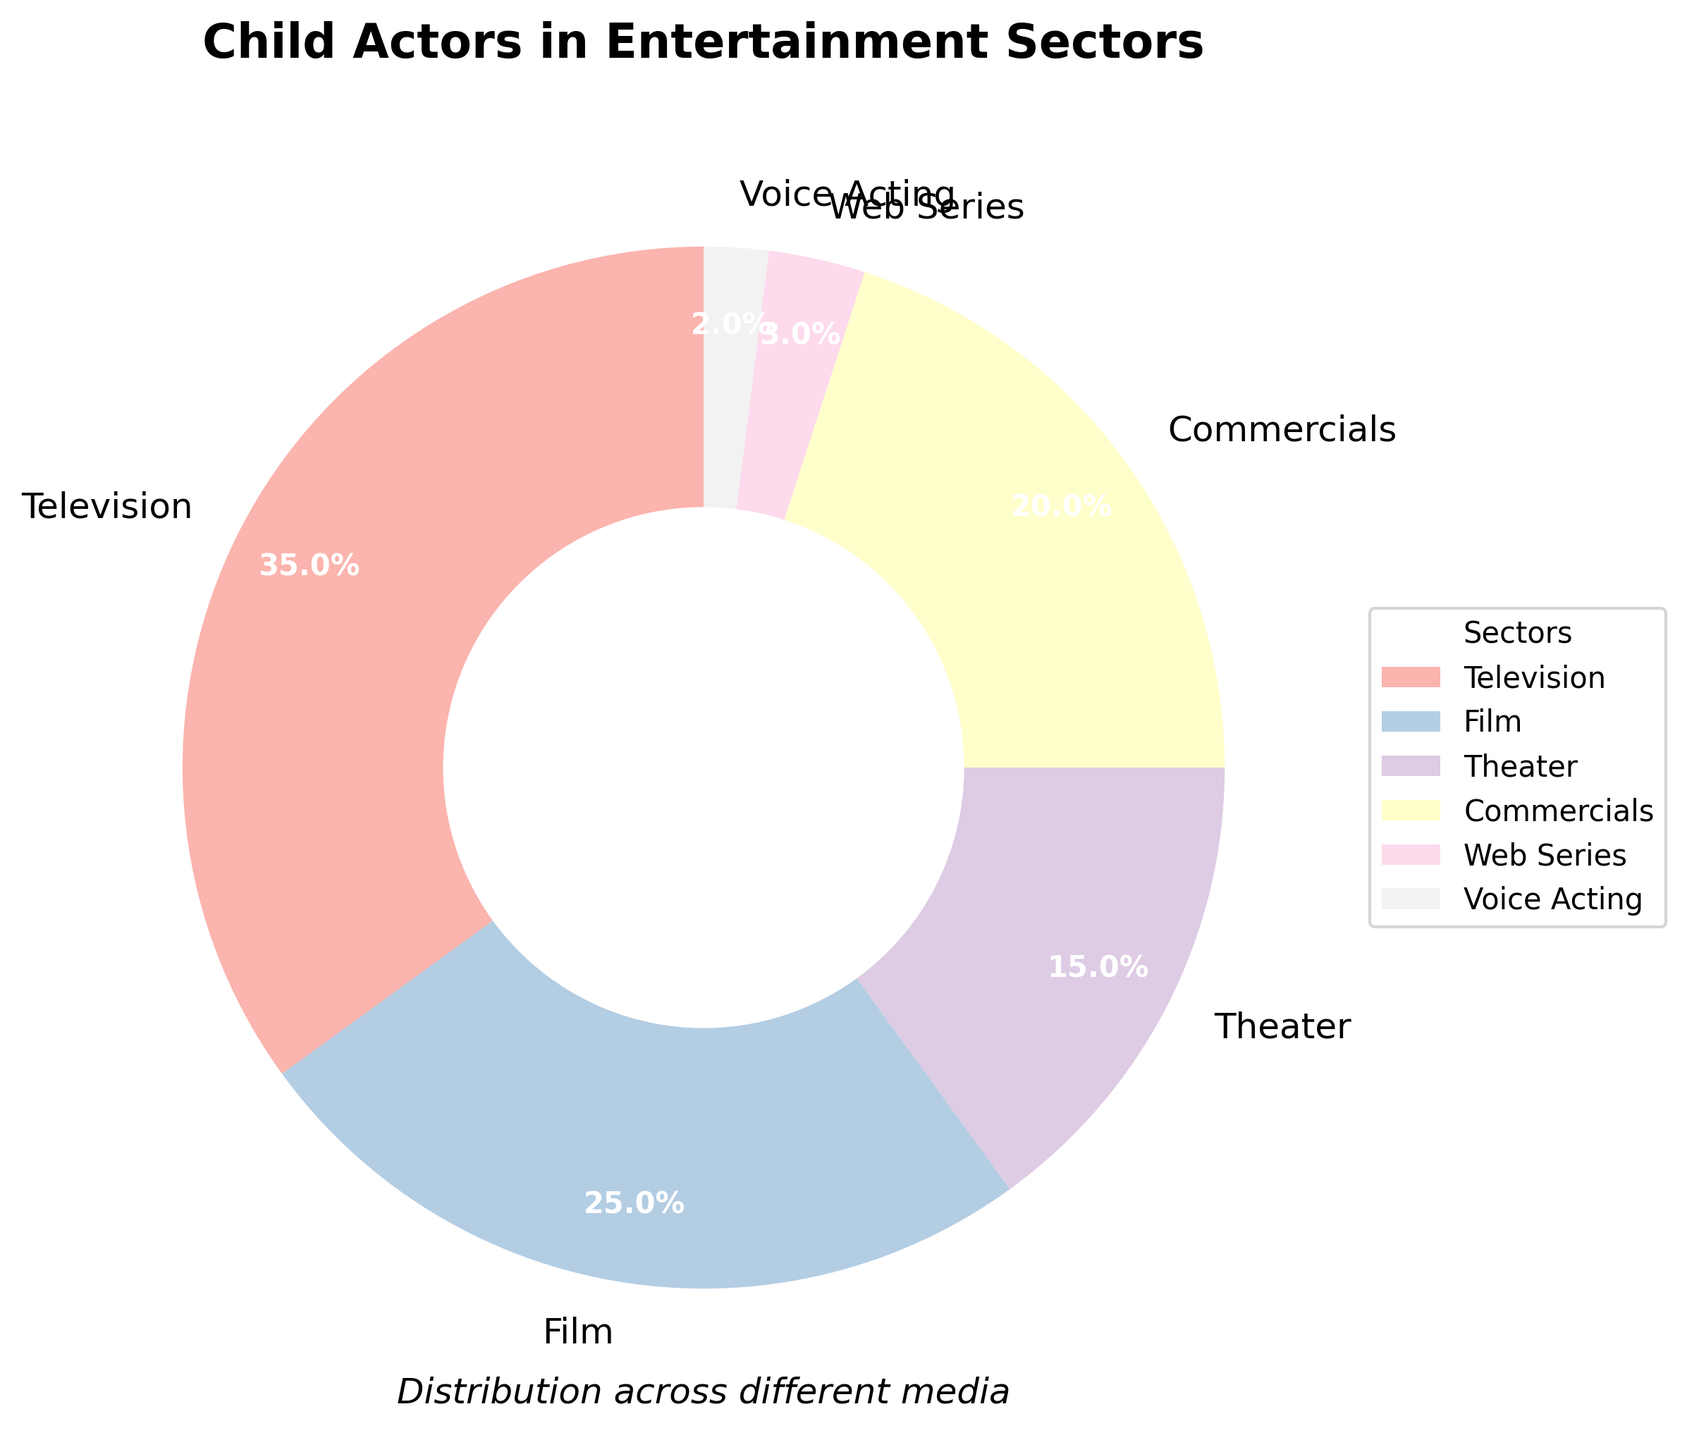What percentage of child actors are involved in television compared to film? The pie chart shows that television has 35% while film has 25%. To compare, the difference is 35% - 25%.
Answer: Television: 35%, Film: 25% Which sector has the least percentage of child actors, and what is that percentage? The pie chart details percentages for each sector with Voice Acting having the smallest segment.
Answer: Voice Acting: 2% What is the combined percentage of child actors involved in theater and commercials? From the pie chart, theater has 15% and commercials have 20%. Adding these together gives 15% + 20%.
Answer: 35% How does the percentage of child actors in web series compare to that in film? Comparing the segments of the pie chart, we see web series at 3% and film at 25%. To see how they compare, we take 25% - 3%.
Answer: Web Series: 3%, Film: 25% Are there more child actors in commercials or voice acting, and by how much? The chart shows 20% in commercials and 2% in voice acting. The difference is 20% - 2%.
Answer: Commercials by 18% What sector has the second highest percentage of child actors? The pie chart labels show that the sector with the second highest percentage is film at 25%.
Answer: Film What percentage of child actors are in sectors other than film? Film accounts for 25%, so subtract this from 100%. 100% - 25%.
Answer: 75% Which sector has a larger percentage of child actors: web series or theater? The chart shows that theater has 15% and web series has 3%, so theater has a larger percentage.
Answer: Theater: 15%, Web Series: 3% What is the total percentage of child actors involved in sectors shown with less than 20% each? Combining the percentages of theater (15%), web series (3%), and voice acting (2%), we get 15% + 3% + 2%.
Answer: 20% 